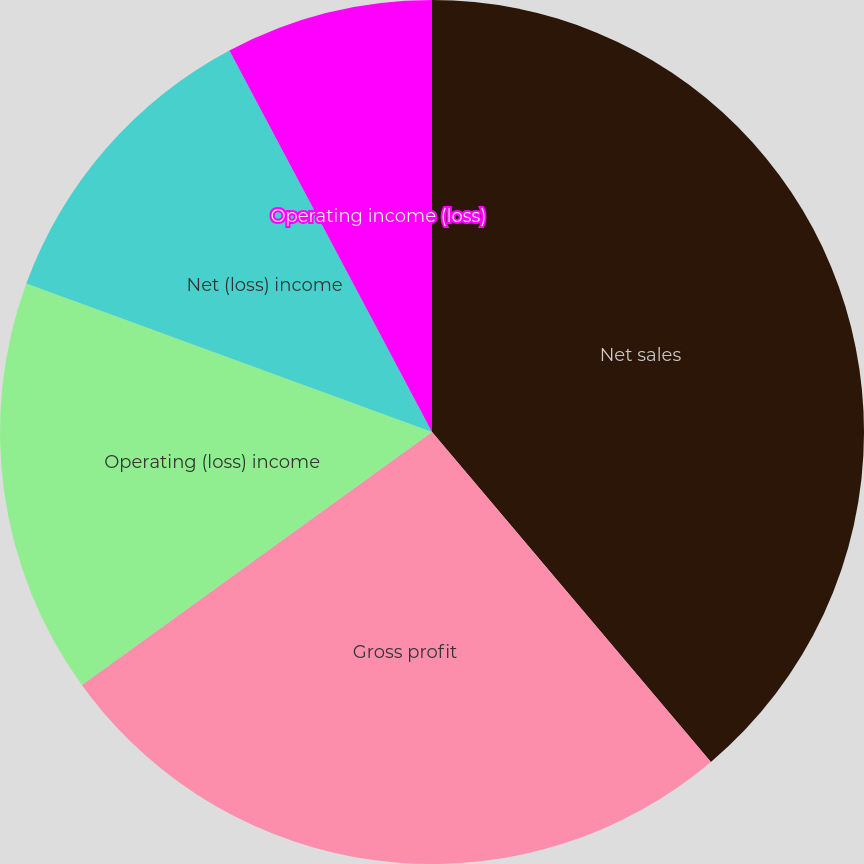<chart> <loc_0><loc_0><loc_500><loc_500><pie_chart><fcel>Net sales<fcel>Gross profit<fcel>Operating (loss) income<fcel>Net (loss) income<fcel>Net (loss) income per common<fcel>Operating income (loss)<nl><fcel>38.83%<fcel>26.21%<fcel>15.54%<fcel>11.65%<fcel>0.0%<fcel>7.77%<nl></chart> 